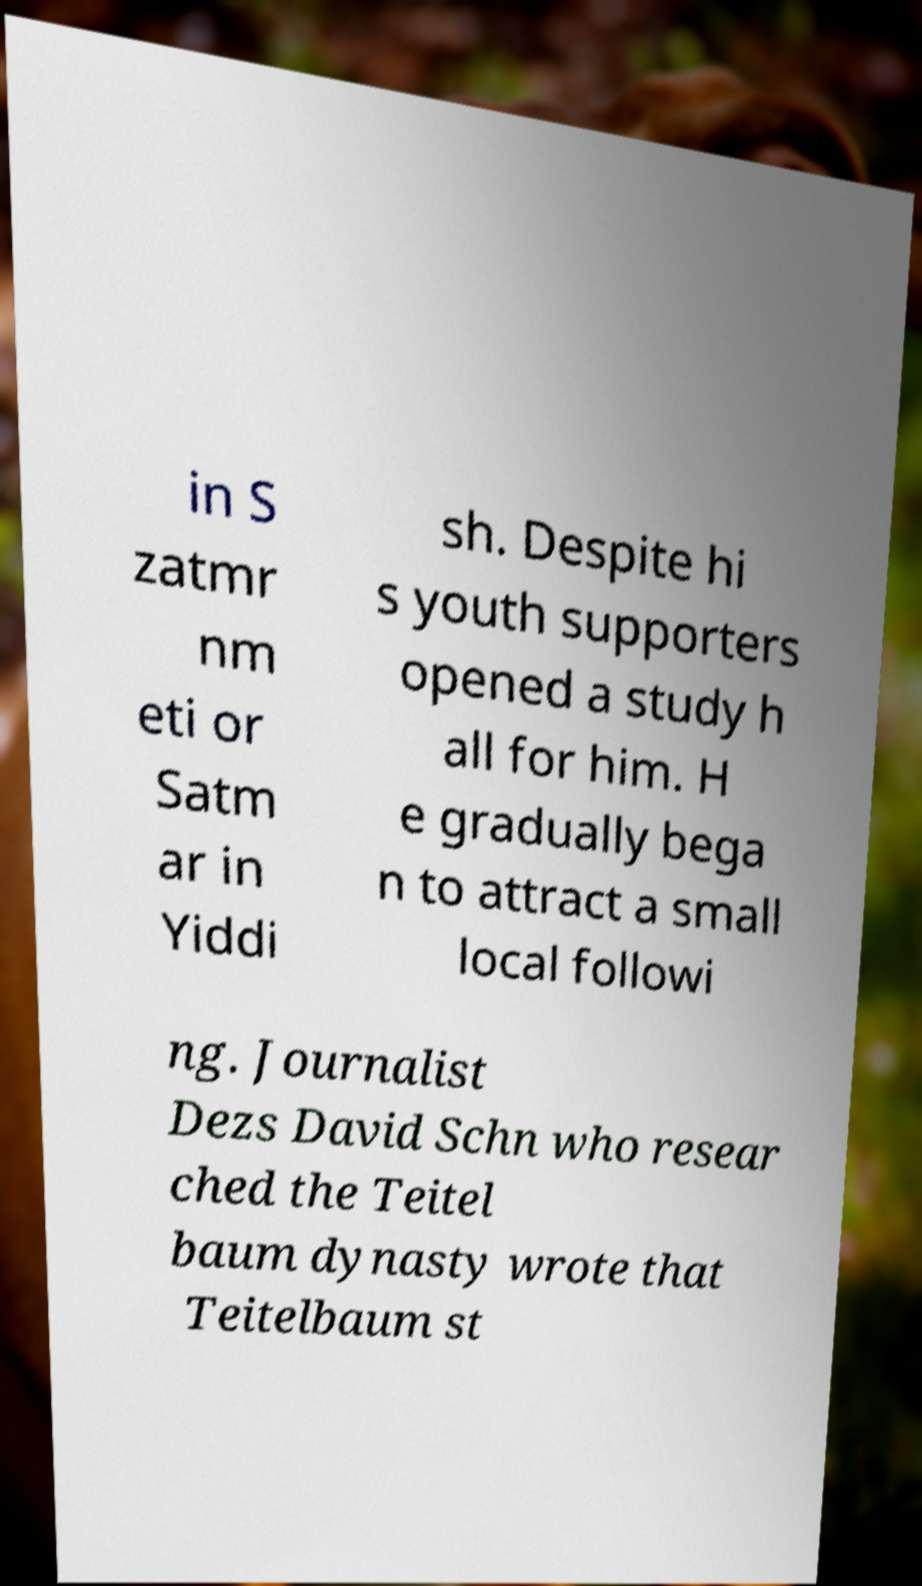Could you assist in decoding the text presented in this image and type it out clearly? in S zatmr nm eti or Satm ar in Yiddi sh. Despite hi s youth supporters opened a study h all for him. H e gradually bega n to attract a small local followi ng. Journalist Dezs David Schn who resear ched the Teitel baum dynasty wrote that Teitelbaum st 